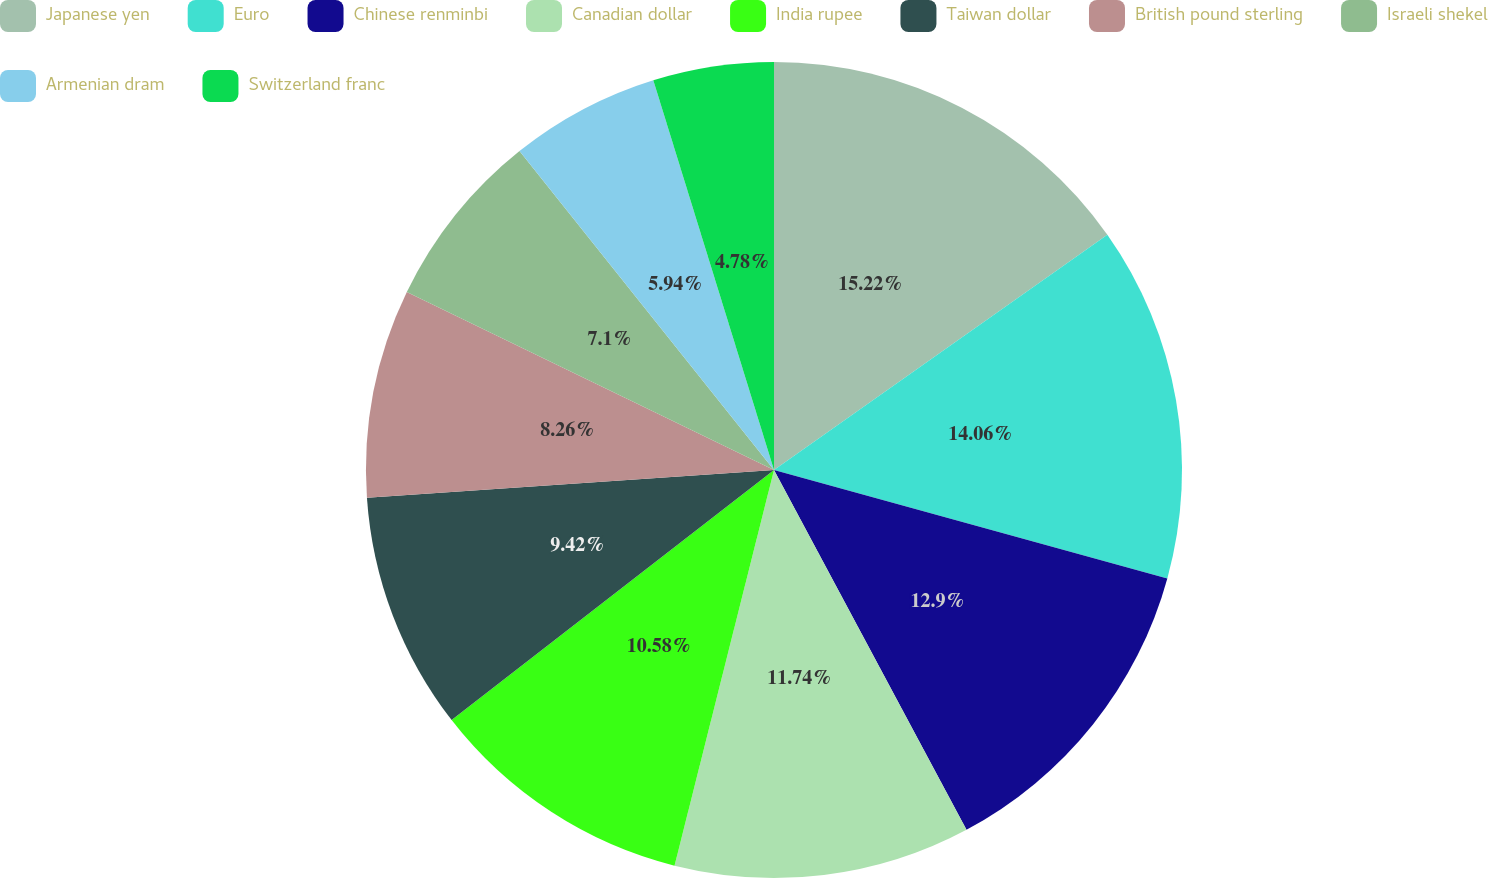Convert chart to OTSL. <chart><loc_0><loc_0><loc_500><loc_500><pie_chart><fcel>Japanese yen<fcel>Euro<fcel>Chinese renminbi<fcel>Canadian dollar<fcel>India rupee<fcel>Taiwan dollar<fcel>British pound sterling<fcel>Israeli shekel<fcel>Armenian dram<fcel>Switzerland franc<nl><fcel>15.22%<fcel>14.06%<fcel>12.9%<fcel>11.74%<fcel>10.58%<fcel>9.42%<fcel>8.26%<fcel>7.1%<fcel>5.94%<fcel>4.78%<nl></chart> 